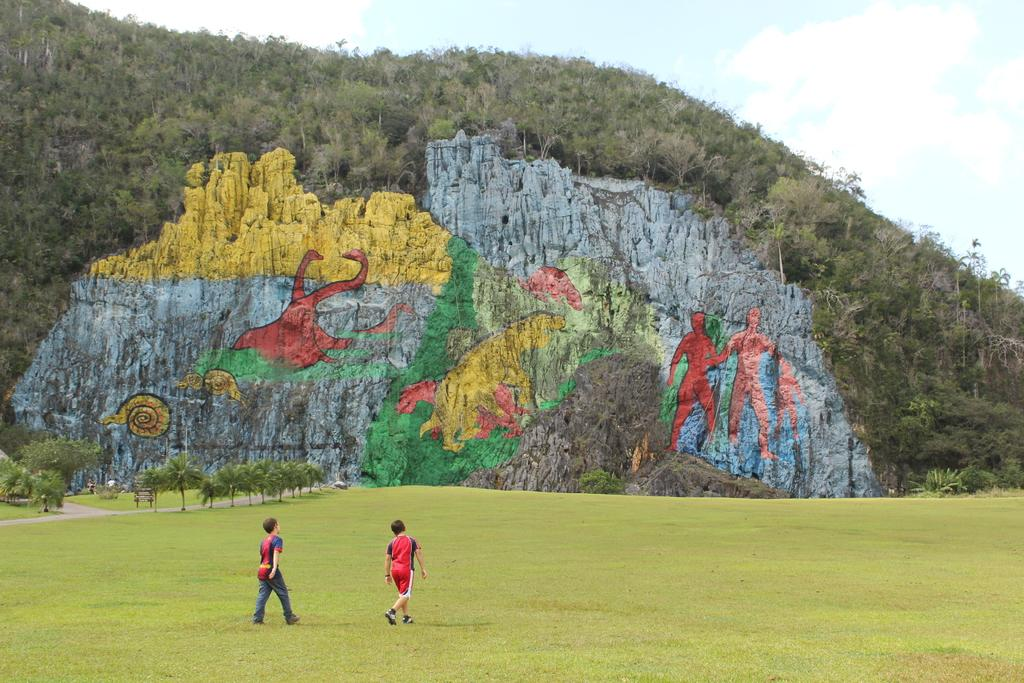How many people are walking in the image? There are two persons walking in the image. What type of terrain can be seen under their feet? There is grass on the ground in the image. What is the rock with writing on it called? There is a rock with graffiti in the image. What type of vegetation is present in the image? There are trees in the image. What is visible in the background of the image? The sky is visible in the image, and clouds are present in the sky. What type of nut is being used to make butter in the image? There is no nut or butter present in the image; it features two persons walking, grass, a rock with graffiti, trees, and a sky with clouds. 